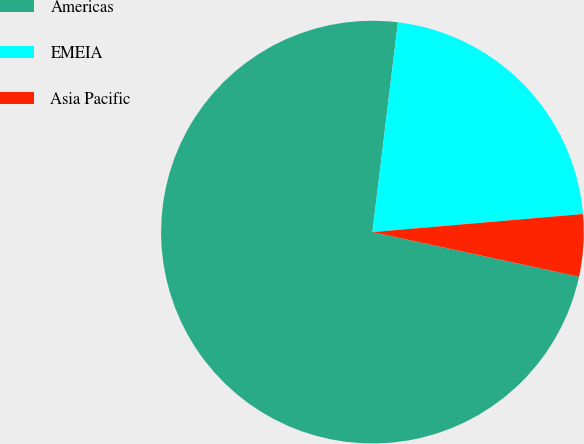Convert chart to OTSL. <chart><loc_0><loc_0><loc_500><loc_500><pie_chart><fcel>Americas<fcel>EMEIA<fcel>Asia Pacific<nl><fcel>73.53%<fcel>21.71%<fcel>4.75%<nl></chart> 